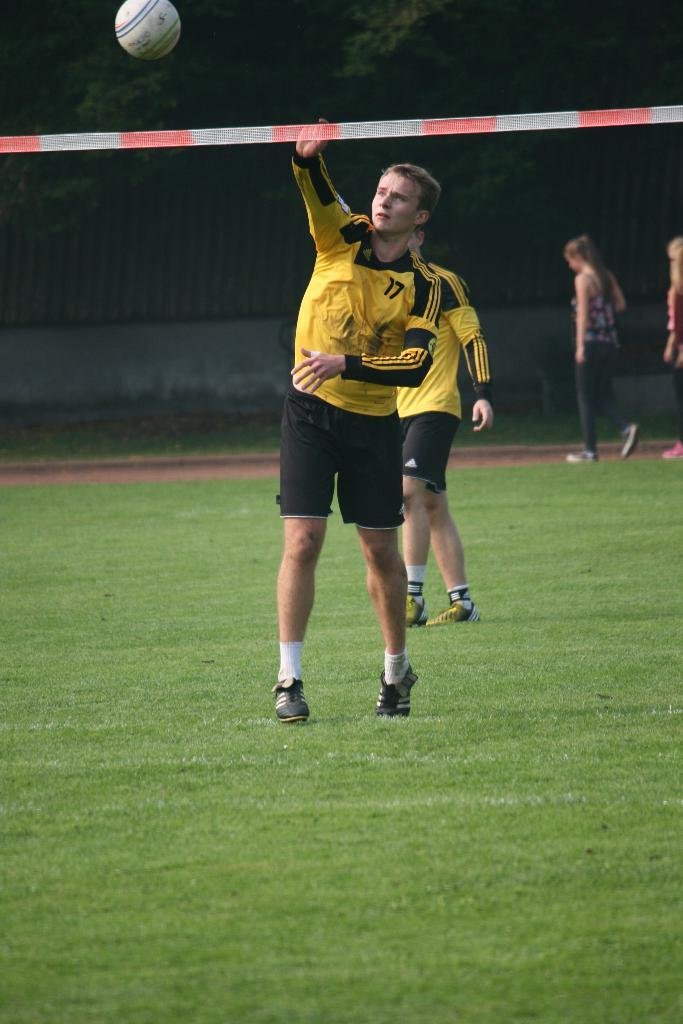What sport are the players engaged in within the image? The players are playing football in the image. Where is the football game taking place? The football game is taking place on a ground. What can be seen in the background of the image? There are people walking and a wall in the background of the image. What type of vegetation is visible in the background? There are trees in the background of the image. What type of glass is being used by the players to play football in the image? There is no glass present in the image; the players are using a football. How does the belief system of the players affect their performance in the image? There is no information about the players' belief systems in the image, so it cannot be determined how it affects their performance. 